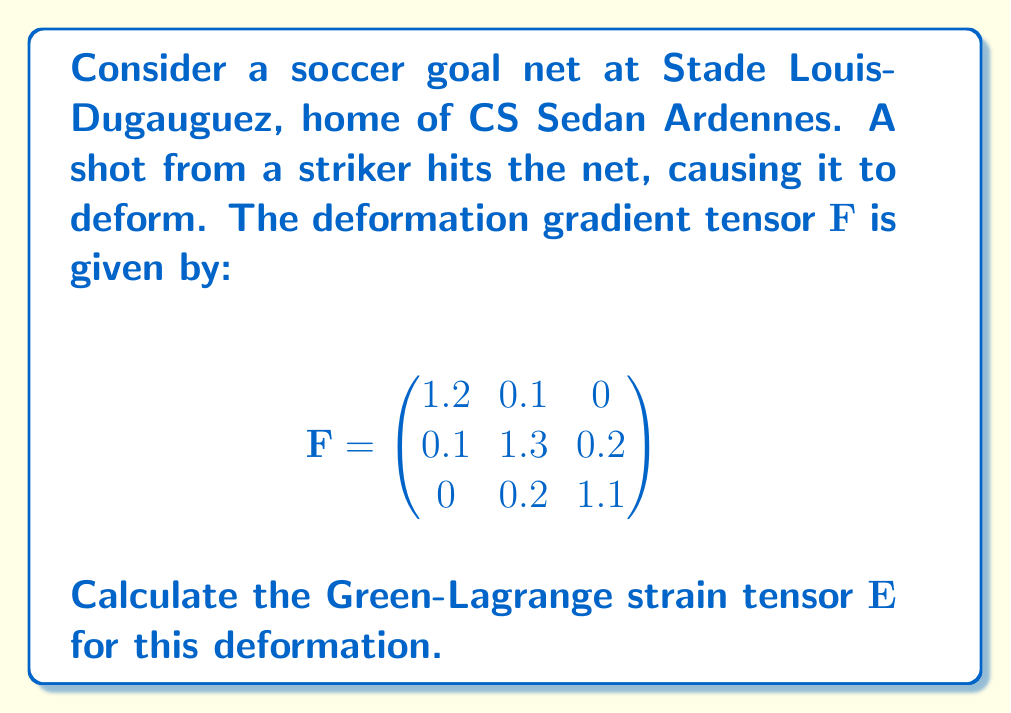Could you help me with this problem? To solve this problem, we'll follow these steps:

1) Recall that the Green-Lagrange strain tensor $\mathbf{E}$ is defined as:

   $$\mathbf{E} = \frac{1}{2}(\mathbf{F}^T\mathbf{F} - \mathbf{I})$$

   where $\mathbf{F}^T$ is the transpose of $\mathbf{F}$, and $\mathbf{I}$ is the identity matrix.

2) First, let's calculate $\mathbf{F}^T$:

   $$\mathbf{F}^T = \begin{pmatrix}
   1.2 & 0.1 & 0 \\
   0.1 & 1.3 & 0.2 \\
   0 & 0.2 & 1.1
   \end{pmatrix}$$

3) Now, let's multiply $\mathbf{F}^T$ and $\mathbf{F}$:

   $$\mathbf{F}^T\mathbf{F} = \begin{pmatrix}
   1.45 & 0.25 & 0.02 \\
   0.25 & 1.74 & 0.44 \\
   0.02 & 0.44 & 1.25
   \end{pmatrix}$$

4) Next, we subtract the identity matrix $\mathbf{I}$:

   $$\mathbf{F}^T\mathbf{F} - \mathbf{I} = \begin{pmatrix}
   0.45 & 0.25 & 0.02 \\
   0.25 & 0.74 & 0.44 \\
   0.02 & 0.44 & 0.25
   \end{pmatrix}$$

5) Finally, we multiply by $\frac{1}{2}$ to get $\mathbf{E}$:

   $$\mathbf{E} = \frac{1}{2}\begin{pmatrix}
   0.45 & 0.25 & 0.02 \\
   0.25 & 0.74 & 0.44 \\
   0.02 & 0.44 & 0.25
   \end{pmatrix} = \begin{pmatrix}
   0.225 & 0.125 & 0.01 \\
   0.125 & 0.37 & 0.22 \\
   0.01 & 0.22 & 0.125
   \end{pmatrix}$$

This Green-Lagrange strain tensor $\mathbf{E}$ represents the deformation of the CS Sedan Ardennes goal net upon impact from the striker's shot.
Answer: $$\mathbf{E} = \begin{pmatrix}
0.225 & 0.125 & 0.01 \\
0.125 & 0.37 & 0.22 \\
0.01 & 0.22 & 0.125
\end{pmatrix}$$ 